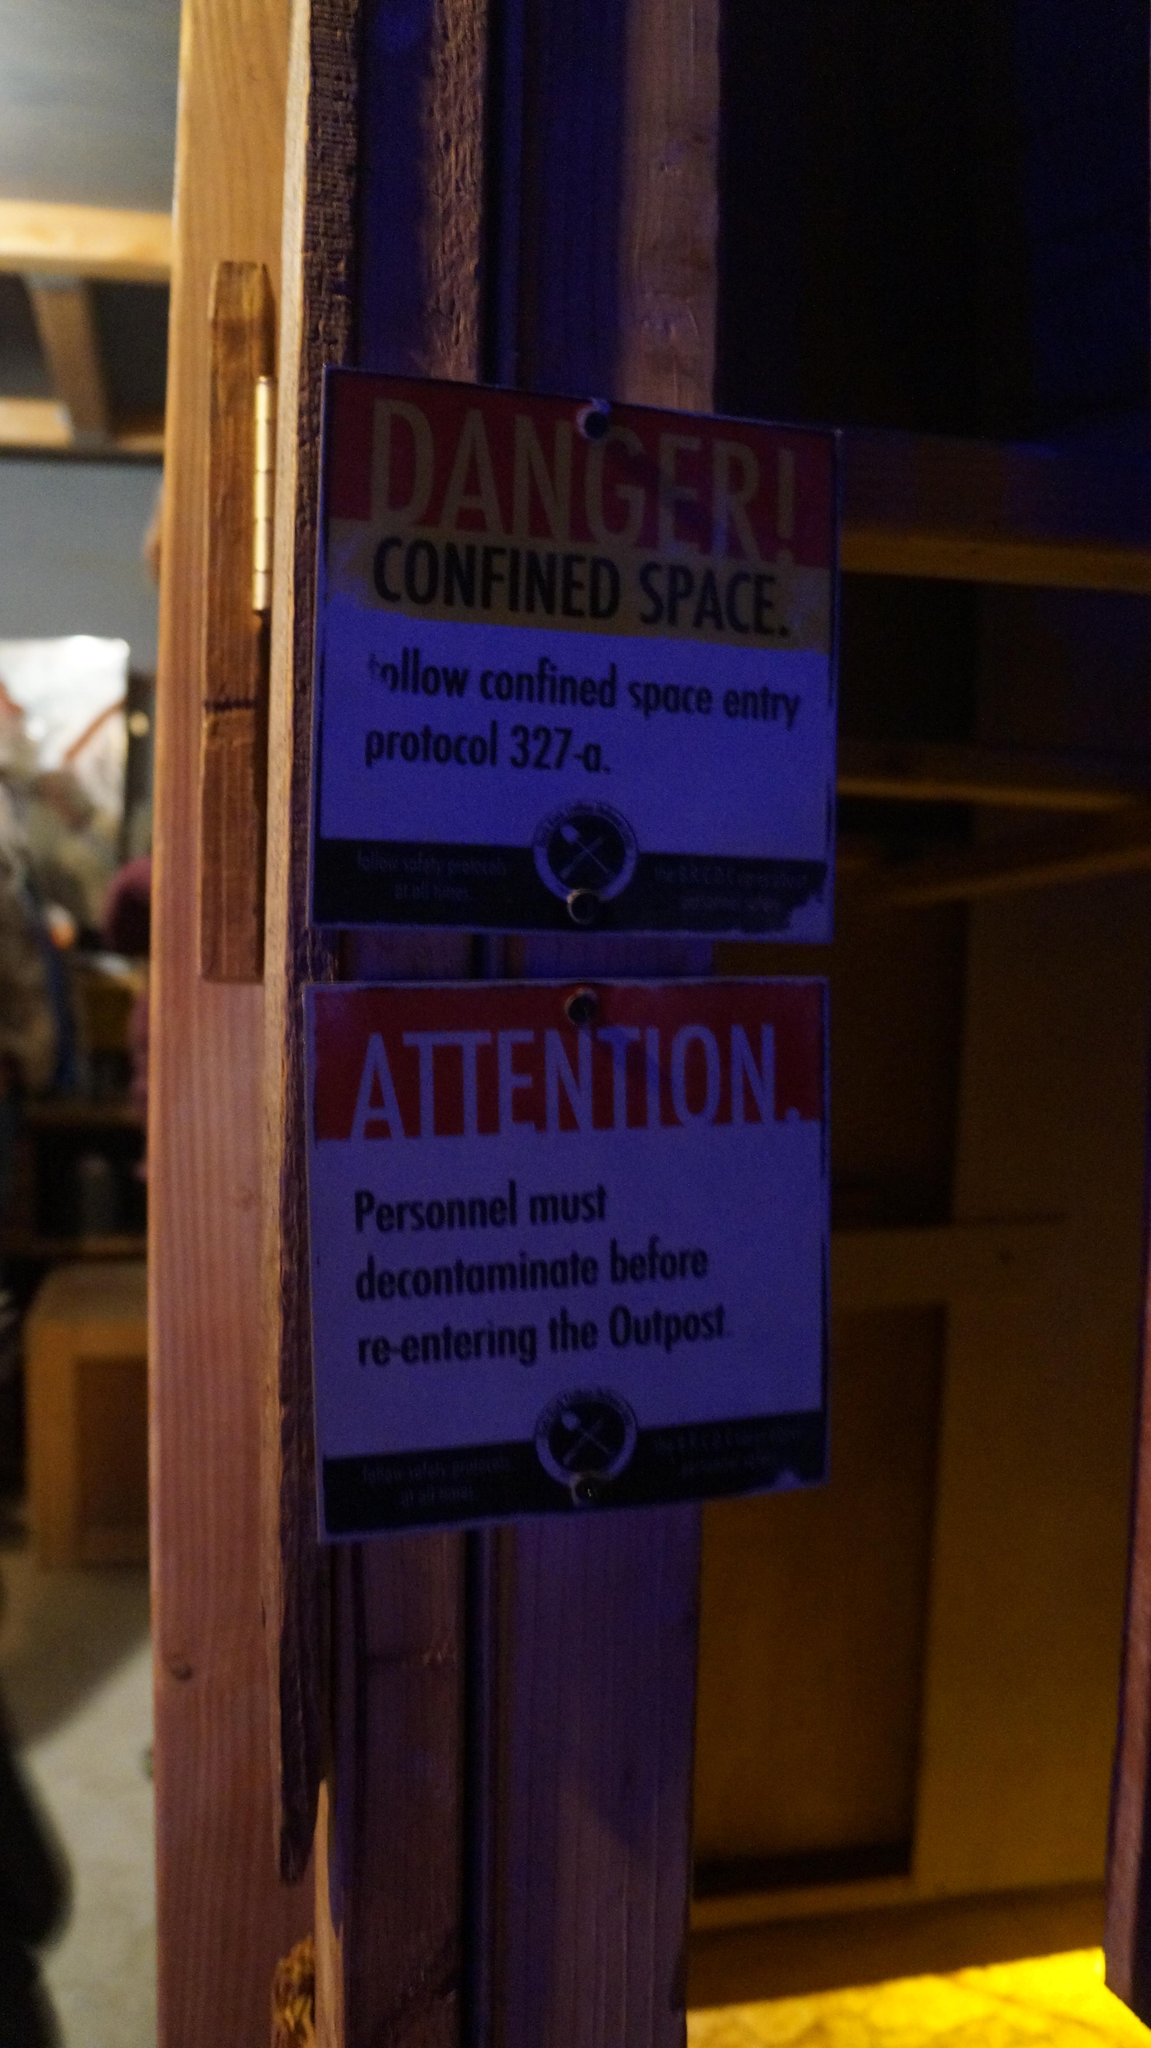What is the main object in the image? There is a danger board in the image. How is the danger board attached? The danger board is attached to a wooden pole. What can be seen in the background of the image? There is a ceiling and a floor visible in the background of the image. What type of club is located in the library in the image? There is no club or library present in the image; it only features a danger board attached to a wooden pole. Which direction is the danger board facing in the image? The provided facts do not mention the direction the danger board is facing, so we cannot determine its orientation from the image. 